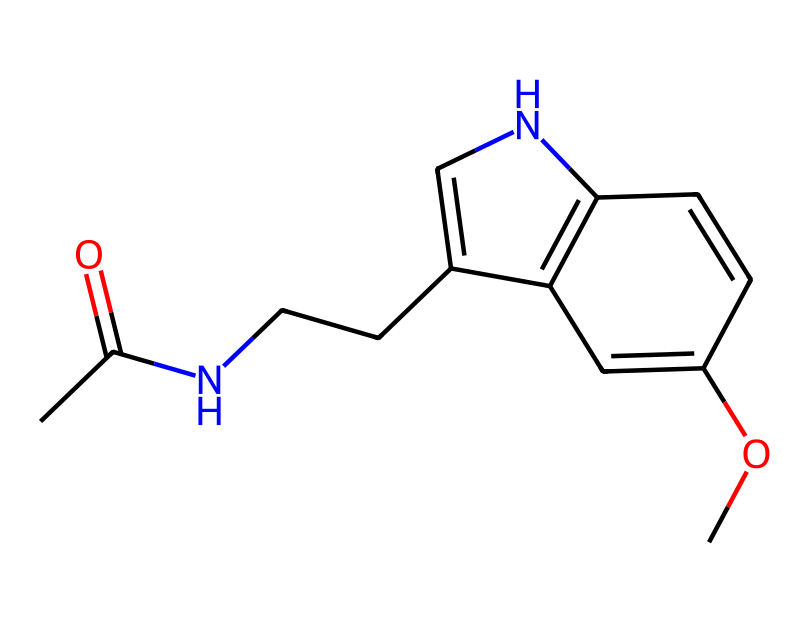What is the molecular formula of melatonin? To determine the molecular formula, you need to count each type of atom present in the SMILES representation. The SMILES indicates there are 13 carbon (C) atoms, 16 hydrogen (H) atoms, 1 nitrogen (N) atom, and 2 oxygen (O) atoms. Therefore, the molecular formula is C13H16N2O2.
Answer: C13H16N2O2 How many rings are present in the structure of melatonin? By analyzing the SMILES representation, we see that there is one cyclic structure indicated by the '1' and '2' numbers, showing it is a fused ring system. Thus, there is 1 ring system.
Answer: 1 What functional groups can be identified in melatonin? In the chemical structure, we can identify an amide group (due to the presence of the 'N' and a carbonyl 'C(=O)') and a methoxy group (the '-O' next to a carbon). Therefore, the identified functional groups are an amide and ether.
Answer: amide, ether Is melatonin primarily soluble in water or organic solvents? Considering the hydrophobic parts of the molecule like the alkyl side chains and the aromatic ring structure, melatonin is more likely to be soluble in organic solvents due to its non-polar characteristics.
Answer: organic solvents What role does melatonin play in the human body? Melatonin's primary function in the body is to regulate sleep-wake cycles, signaling the body when it's time to sleep, leading to its classification as a hormone.
Answer: sleep regulation What type of bonding is predominantly present in melatonin? The structure of melatonin predominantly exhibits covalent bonding, as it consists of atoms sharing electrons to form stable molecules, which is typical for organic compounds.
Answer: covalent How does the nitrogen atom contribute to melatonin’s function? The nitrogen atom in melatonin is part of the indole structure, which is crucial for receptor binding in the brain, facilitating its role in the sleep regulation mechanism.
Answer: receptor binding 